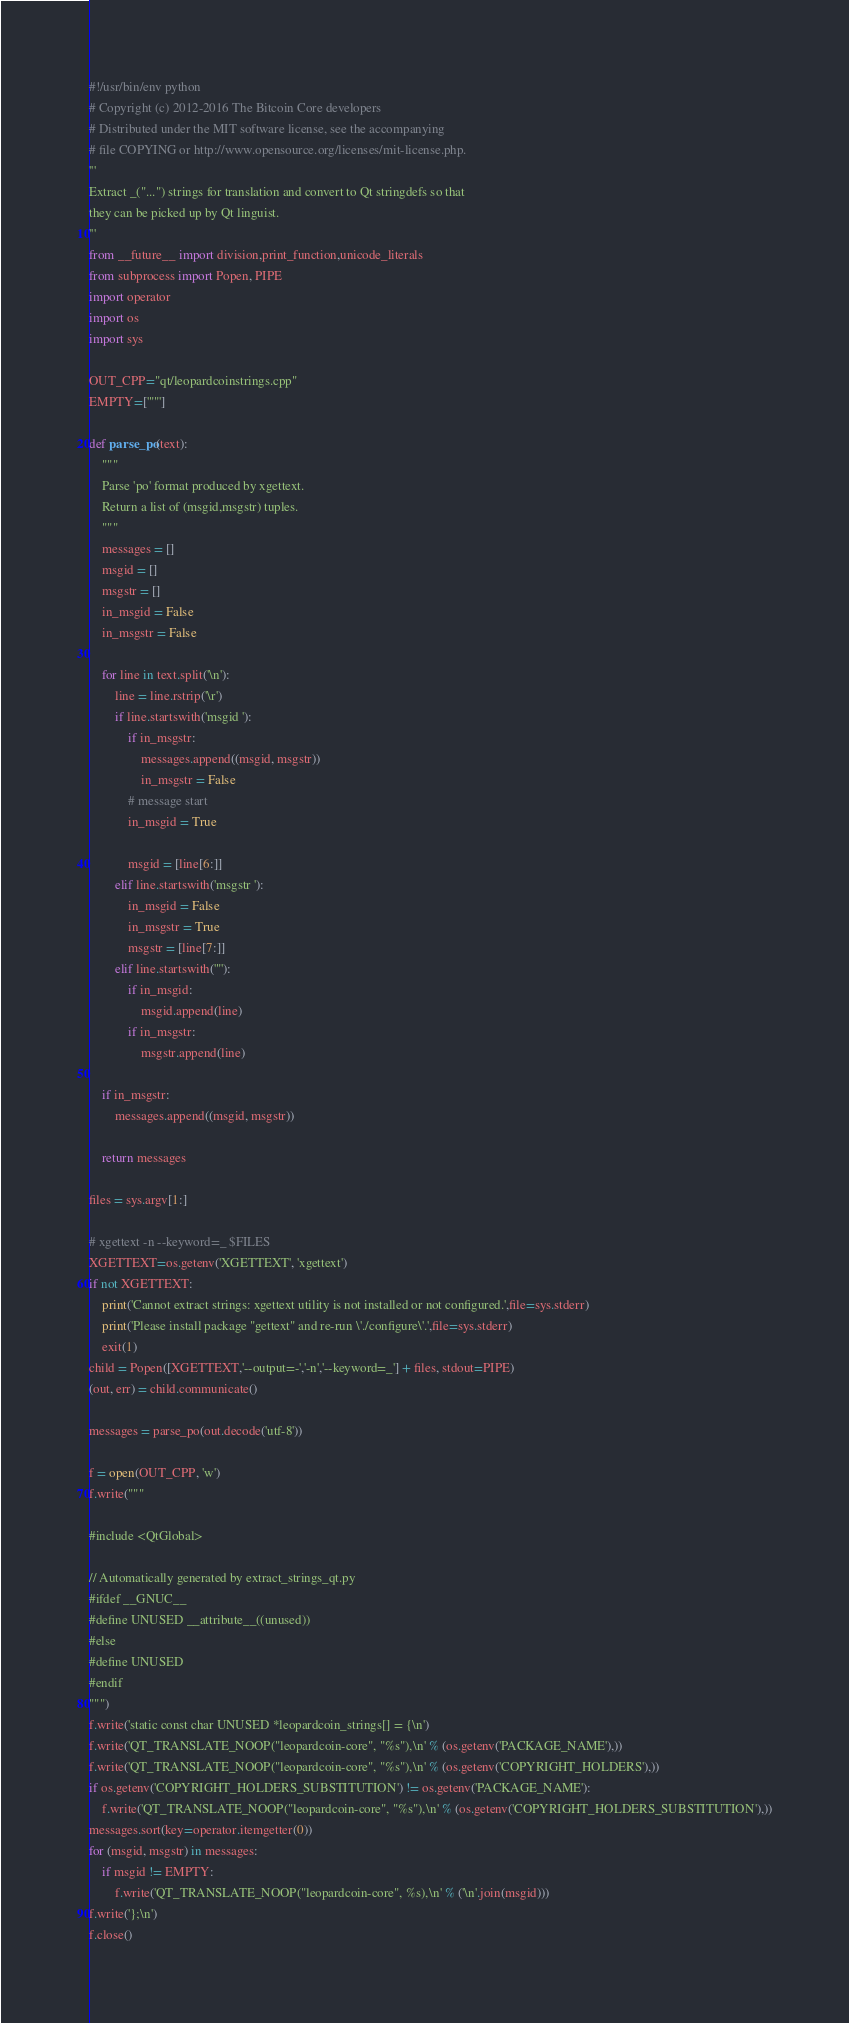<code> <loc_0><loc_0><loc_500><loc_500><_Python_>#!/usr/bin/env python
# Copyright (c) 2012-2016 The Bitcoin Core developers
# Distributed under the MIT software license, see the accompanying
# file COPYING or http://www.opensource.org/licenses/mit-license.php.
'''
Extract _("...") strings for translation and convert to Qt stringdefs so that
they can be picked up by Qt linguist.
'''
from __future__ import division,print_function,unicode_literals
from subprocess import Popen, PIPE
import operator
import os
import sys

OUT_CPP="qt/leopardcoinstrings.cpp"
EMPTY=['""']

def parse_po(text):
    """
    Parse 'po' format produced by xgettext.
    Return a list of (msgid,msgstr) tuples.
    """
    messages = []
    msgid = []
    msgstr = []
    in_msgid = False
    in_msgstr = False

    for line in text.split('\n'):
        line = line.rstrip('\r')
        if line.startswith('msgid '):
            if in_msgstr:
                messages.append((msgid, msgstr))
                in_msgstr = False
            # message start
            in_msgid = True

            msgid = [line[6:]]
        elif line.startswith('msgstr '):
            in_msgid = False
            in_msgstr = True
            msgstr = [line[7:]]
        elif line.startswith('"'):
            if in_msgid:
                msgid.append(line)
            if in_msgstr:
                msgstr.append(line)

    if in_msgstr:
        messages.append((msgid, msgstr))

    return messages

files = sys.argv[1:]

# xgettext -n --keyword=_ $FILES
XGETTEXT=os.getenv('XGETTEXT', 'xgettext')
if not XGETTEXT:
    print('Cannot extract strings: xgettext utility is not installed or not configured.',file=sys.stderr)
    print('Please install package "gettext" and re-run \'./configure\'.',file=sys.stderr)
    exit(1)
child = Popen([XGETTEXT,'--output=-','-n','--keyword=_'] + files, stdout=PIPE)
(out, err) = child.communicate()

messages = parse_po(out.decode('utf-8'))

f = open(OUT_CPP, 'w')
f.write("""

#include <QtGlobal>

// Automatically generated by extract_strings_qt.py
#ifdef __GNUC__
#define UNUSED __attribute__((unused))
#else
#define UNUSED
#endif
""")
f.write('static const char UNUSED *leopardcoin_strings[] = {\n')
f.write('QT_TRANSLATE_NOOP("leopardcoin-core", "%s"),\n' % (os.getenv('PACKAGE_NAME'),))
f.write('QT_TRANSLATE_NOOP("leopardcoin-core", "%s"),\n' % (os.getenv('COPYRIGHT_HOLDERS'),))
if os.getenv('COPYRIGHT_HOLDERS_SUBSTITUTION') != os.getenv('PACKAGE_NAME'):
    f.write('QT_TRANSLATE_NOOP("leopardcoin-core", "%s"),\n' % (os.getenv('COPYRIGHT_HOLDERS_SUBSTITUTION'),))
messages.sort(key=operator.itemgetter(0))
for (msgid, msgstr) in messages:
    if msgid != EMPTY:
        f.write('QT_TRANSLATE_NOOP("leopardcoin-core", %s),\n' % ('\n'.join(msgid)))
f.write('};\n')
f.close()
</code> 